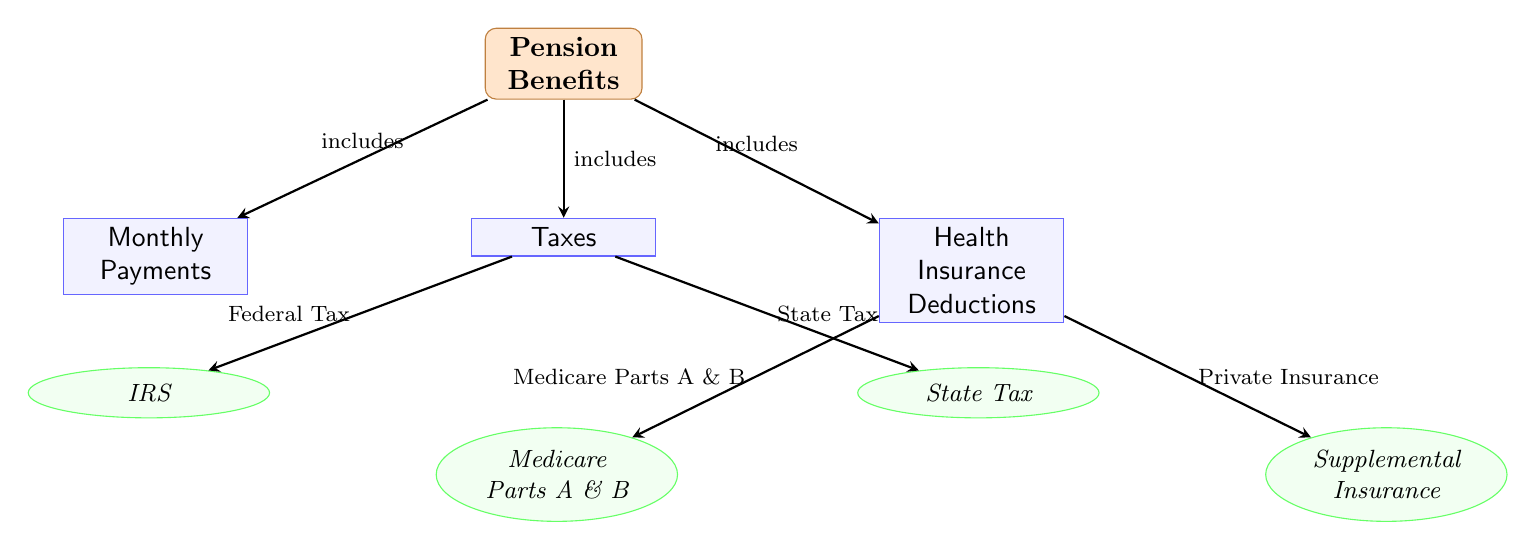What are the three main components of Pension Benefits? The diagram lists three main components: Monthly Payments, Taxes, and Health Insurance Deductions as the categories that make up Pension Benefits.
Answer: Monthly Payments, Taxes, Health Insurance Deductions Which entity is associated with Federal Tax? According to the diagram, Federal Tax is connected to the entity labeled IRS, indicating that the IRS is involved in this aspect of Taxes.
Answer: IRS How many entities are associated with Health Insurance Deductions? The diagram displays two entities under Health Insurance Deductions: Medicare Parts A & B and Supplemental Insurance, indicating there are two entities associated.
Answer: 2 What type of tax is represented by State Tax? The diagram depicts State Tax as an entity below the Taxes category, confirming that State Tax is a type of tax deducted from Pension Benefits.
Answer: Tax Which two types of health insurance are shown in the diagram? The diagram highlights two specific types of health insurance deductions: Medicare Parts A & B and Supplemental Insurance, illustrating the options available for health insurance deductions.
Answer: Medicare Parts A & B, Supplemental Insurance What is the relationship between Pension Benefits and Monthly Payments? The diagram illustrates a direct relationship through an edge marked "includes," indicating that Monthly Payments are a part of Pension Benefits.
Answer: includes What is the connection between Taxes and State Tax? The diagram shows an edge connecting Taxes and State Tax, labeled as State Tax, which indicates that State Tax is a specific type of tax categorized under Taxes.
Answer: State Tax Which category includes entities related to medical insurance? The Health Insurance Deductions category includes the entities Medicare Parts A & B and Supplemental Insurance, clearly indicating its focus on medical insurance.
Answer: Health Insurance Deductions 